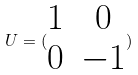<formula> <loc_0><loc_0><loc_500><loc_500>U = ( \begin{matrix} 1 & 0 \\ 0 & - 1 \end{matrix} )</formula> 